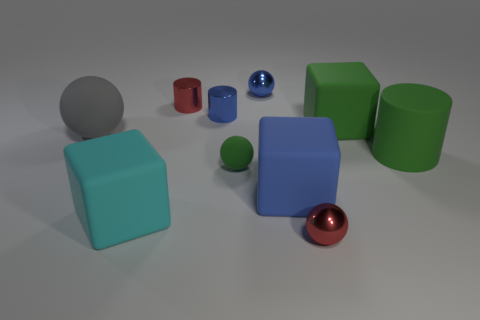Do the cyan cube and the tiny blue thing that is on the right side of the green ball have the same material?
Give a very brief answer. No. There is a big matte cube that is behind the tiny matte ball; is it the same color as the big ball?
Your response must be concise. No. What number of rubber things are both behind the cyan object and in front of the tiny green thing?
Your answer should be very brief. 1. What number of other things are there of the same material as the blue sphere
Provide a succinct answer. 3. Does the small red thing that is in front of the large blue object have the same material as the large ball?
Offer a terse response. No. There is a metal cylinder in front of the small red metal object that is behind the big matte object to the left of the large cyan cube; what is its size?
Your response must be concise. Small. What number of other things are there of the same color as the big cylinder?
Give a very brief answer. 2. What is the shape of the gray rubber thing that is the same size as the green cylinder?
Offer a terse response. Sphere. There is a matte cube behind the blue cube; what size is it?
Your response must be concise. Large. There is a metallic thing in front of the large gray ball; does it have the same color as the large block behind the big green matte cylinder?
Make the answer very short. No. 